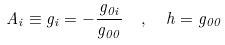Convert formula to latex. <formula><loc_0><loc_0><loc_500><loc_500>A _ { i } \equiv g _ { i } = - \frac { g _ { 0 i } } { g _ { 0 0 } } \ \ , \ \ h = g _ { 0 0 }</formula> 